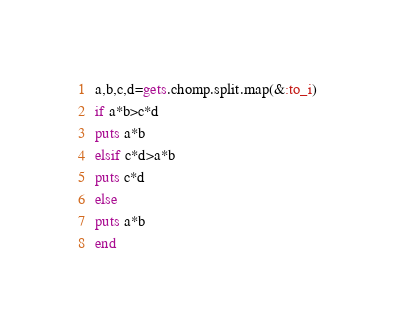<code> <loc_0><loc_0><loc_500><loc_500><_Ruby_>a,b,c,d=gets.chomp.split.map(&:to_i)
if a*b>c*d
puts a*b
elsif c*d>a*b
puts c*d
else
puts a*b
end</code> 